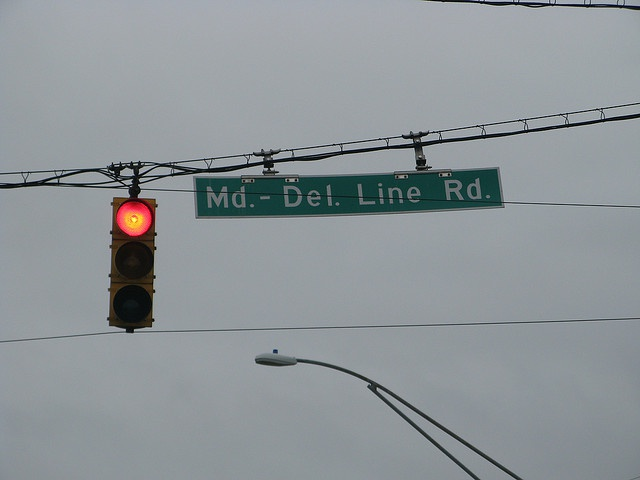Describe the objects in this image and their specific colors. I can see a traffic light in darkgray, black, maroon, and salmon tones in this image. 